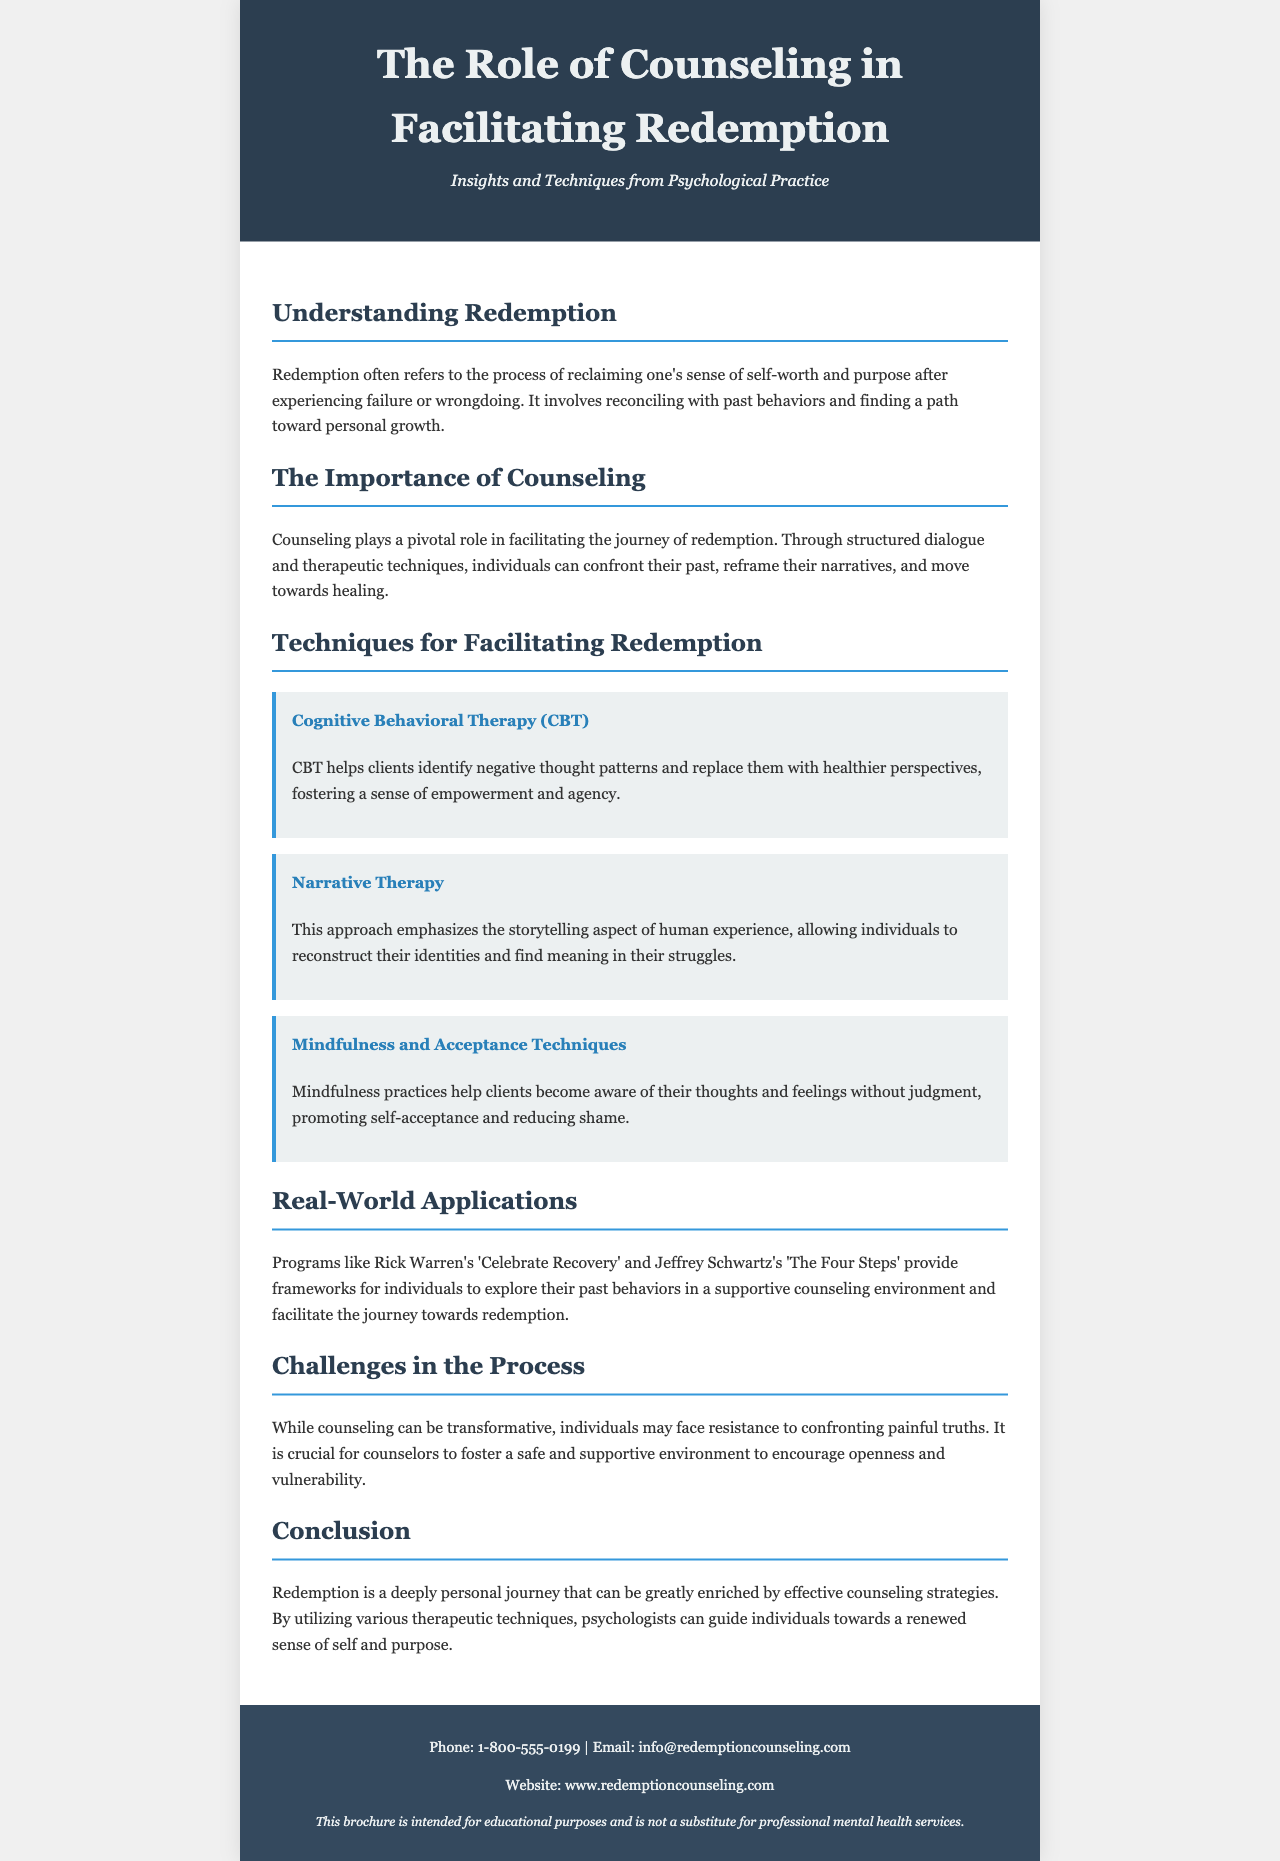What is the main theme of the brochure? The main theme of the brochure centers around the role of counseling in helping individuals achieve redemption through various therapeutic techniques.
Answer: Role of counseling in facilitating redemption What therapeutic technique focuses on storytelling? This technique allows individuals to reconstruct their identities and find meaning in their struggles.
Answer: Narrative Therapy How does Cognitive Behavioral Therapy (CBT) help clients? CBT aids clients in identifying negative thought patterns and replacing them with healthier perspectives.
Answer: Identifying negative thought patterns What are mindfulness practices aimed at promoting? Mindfulness practices are designed to foster self-acceptance and reduce shame in clients during their redemption journey.
Answer: Self-acceptance Which program is mentioned as a framework for exploring past behaviors? This program provides a supportive environment for individuals on their path to redemption.
Answer: Celebrate Recovery What challenge is highlighted in the counseling process? The document states that individuals may face resistance when confronting painful truths, necessitating a safe environment.
Answer: Resistance to confronting painful truths What is the overall conclusion regarding redemption? The conclusion emphasizes that redemption can be enriched through effective counseling strategies and therapeutic techniques.
Answer: Enriched by effective counseling strategies What is a key role of counselors mentioned in the brochure? Counselors are crucial in fostering an environment that encourages openness and vulnerability.
Answer: Encouragement of openness and vulnerability What type of document is this? This document serves an educational purpose related to mental health counseling and redemption.
Answer: Brochure 